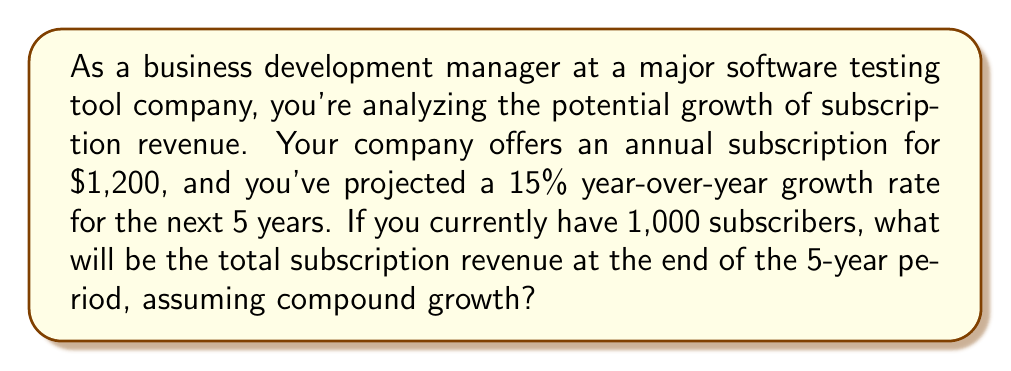Solve this math problem. To solve this problem, we'll use the compound interest formula:

$$A = P(1 + r)^n$$

Where:
$A$ = Final amount
$P$ = Principal (initial) amount
$r$ = Annual growth rate (as a decimal)
$n$ = Number of years

Let's break down the given information:
$P = 1,000 \times \$1,200 = \$1,200,000$ (initial annual revenue)
$r = 15\% = 0.15$
$n = 5$ years

Now, let's substitute these values into the formula:

$$A = 1,200,000(1 + 0.15)^5$$

Let's calculate step by step:

1) First, calculate $(1 + 0.15)^5$:
   $$(1.15)^5 = 2.0113689$$

2) Now, multiply this by the initial amount:
   $$1,200,000 \times 2.0113689 = 2,413,642.68$$

Therefore, the total subscription revenue at the end of the 5-year period will be $\$2,413,642.68$.
Answer: $\$2,413,642.68$ 